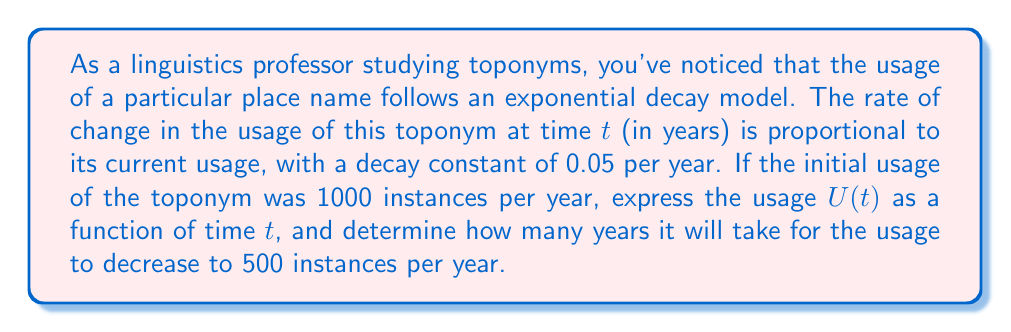Give your solution to this math problem. Let's approach this problem step-by-step using differential equations:

1) First, we need to set up our differential equation. Given that the rate of change is proportional to the current usage, we can write:

   $$\frac{dU}{dt} = -kU$$

   where $k$ is the decay constant, 0.05 per year.

2) This is a separable differential equation. We can solve it as follows:

   $$\frac{dU}{U} = -k dt$$

3) Integrating both sides:

   $$\int \frac{dU}{U} = -k \int dt$$

   $$\ln|U| = -kt + C$$

4) Solving for $U$:

   $$U = e^{-kt + C} = Ae^{-kt}$$

   where $A = e^C$ is a constant we'll determine from the initial condition.

5) We're given that $U(0) = 1000$, so:

   $$1000 = Ae^{-k(0)} = A$$

6) Therefore, our solution is:

   $$U(t) = 1000e^{-0.05t}$$

7) To find when the usage decreases to 500, we solve:

   $$500 = 1000e^{-0.05t}$$

8) Dividing both sides by 1000:

   $$0.5 = e^{-0.05t}$$

9) Taking the natural log of both sides:

   $$\ln(0.5) = -0.05t$$

10) Solving for $t$:

    $$t = \frac{\ln(0.5)}{-0.05} \approx 13.86$$

Therefore, it will take approximately 13.86 years for the usage to decrease to 500 instances per year.
Answer: The usage function is $U(t) = 1000e^{-0.05t}$, and it will take approximately 13.86 years for the usage to decrease to 500 instances per year. 